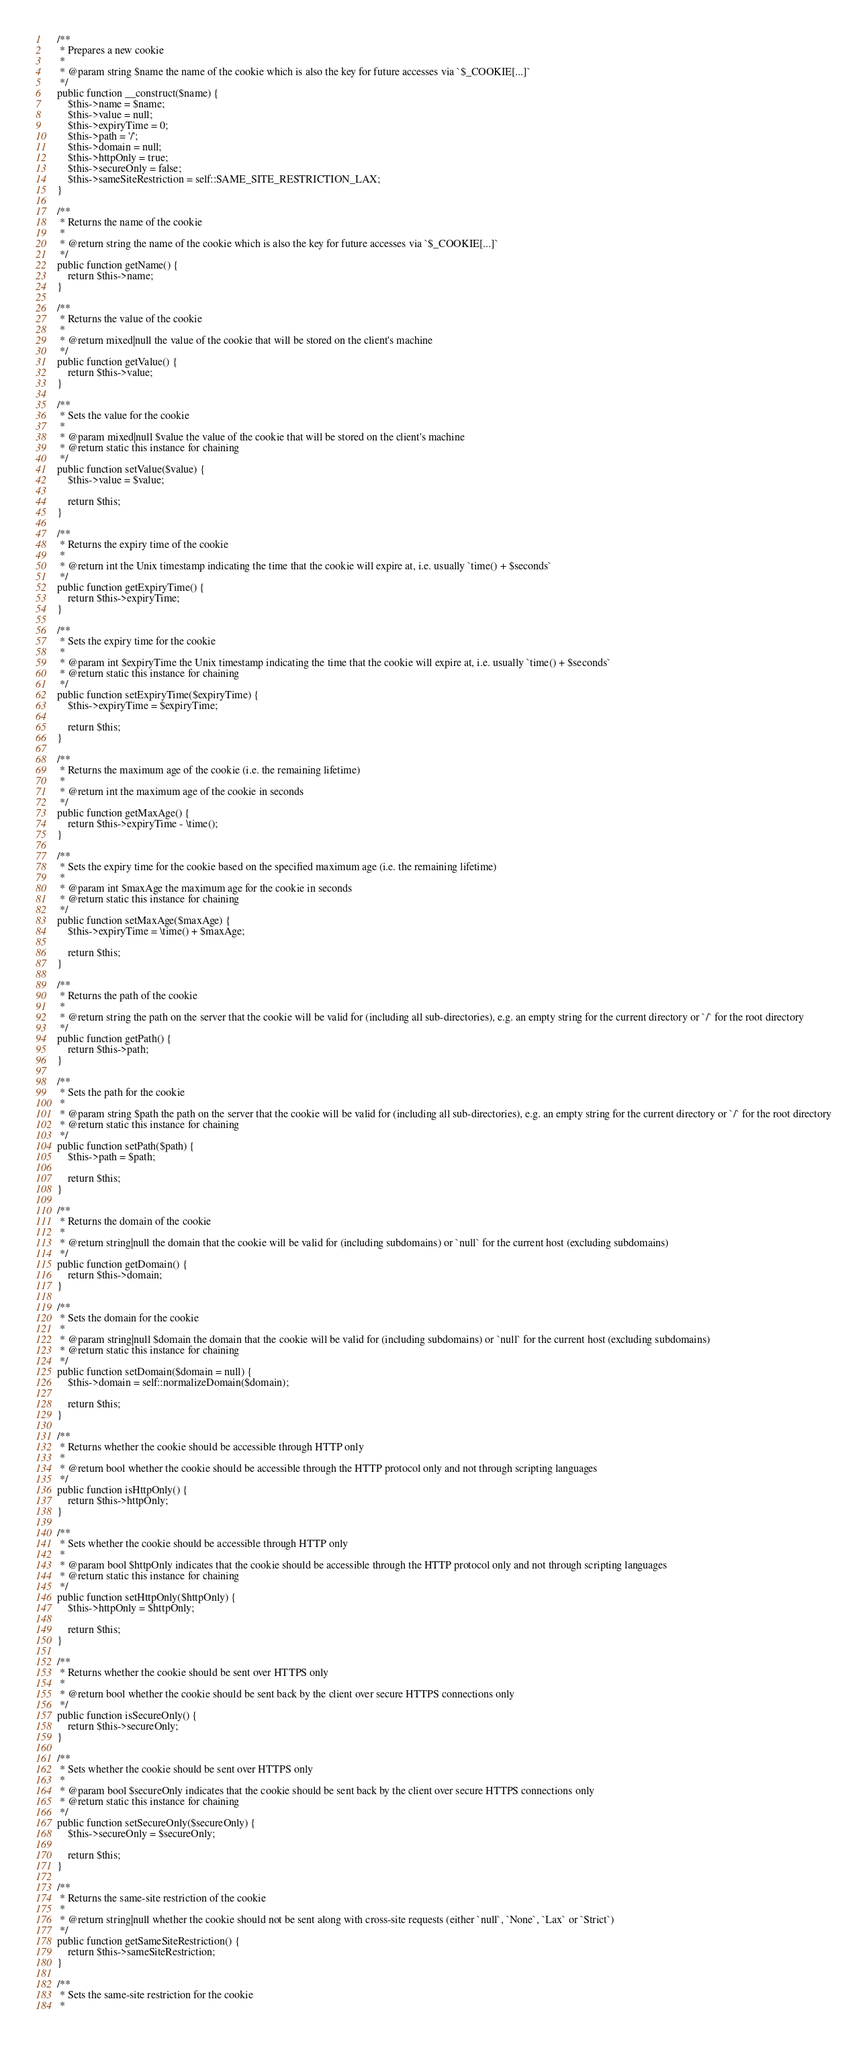Convert code to text. <code><loc_0><loc_0><loc_500><loc_500><_PHP_>
	/**
	 * Prepares a new cookie
	 *
	 * @param string $name the name of the cookie which is also the key for future accesses via `$_COOKIE[...]`
	 */
	public function __construct($name) {
		$this->name = $name;
		$this->value = null;
		$this->expiryTime = 0;
		$this->path = '/';
		$this->domain = null;
		$this->httpOnly = true;
		$this->secureOnly = false;
		$this->sameSiteRestriction = self::SAME_SITE_RESTRICTION_LAX;
	}

	/**
	 * Returns the name of the cookie
	 *
	 * @return string the name of the cookie which is also the key for future accesses via `$_COOKIE[...]`
	 */
	public function getName() {
		return $this->name;
	}

	/**
	 * Returns the value of the cookie
	 *
	 * @return mixed|null the value of the cookie that will be stored on the client's machine
	 */
	public function getValue() {
		return $this->value;
	}

	/**
	 * Sets the value for the cookie
	 *
	 * @param mixed|null $value the value of the cookie that will be stored on the client's machine
	 * @return static this instance for chaining
	 */
	public function setValue($value) {
		$this->value = $value;

		return $this;
	}

	/**
	 * Returns the expiry time of the cookie
	 *
	 * @return int the Unix timestamp indicating the time that the cookie will expire at, i.e. usually `time() + $seconds`
	 */
	public function getExpiryTime() {
		return $this->expiryTime;
	}

	/**
	 * Sets the expiry time for the cookie
	 *
	 * @param int $expiryTime the Unix timestamp indicating the time that the cookie will expire at, i.e. usually `time() + $seconds`
	 * @return static this instance for chaining
	 */
	public function setExpiryTime($expiryTime) {
		$this->expiryTime = $expiryTime;

		return $this;
	}

	/**
	 * Returns the maximum age of the cookie (i.e. the remaining lifetime)
	 *
	 * @return int the maximum age of the cookie in seconds
	 */
	public function getMaxAge() {
		return $this->expiryTime - \time();
	}

	/**
	 * Sets the expiry time for the cookie based on the specified maximum age (i.e. the remaining lifetime)
	 *
	 * @param int $maxAge the maximum age for the cookie in seconds
	 * @return static this instance for chaining
	 */
	public function setMaxAge($maxAge) {
		$this->expiryTime = \time() + $maxAge;

		return $this;
	}

	/**
	 * Returns the path of the cookie
	 *
	 * @return string the path on the server that the cookie will be valid for (including all sub-directories), e.g. an empty string for the current directory or `/` for the root directory
	 */
	public function getPath() {
		return $this->path;
	}

	/**
	 * Sets the path for the cookie
	 *
	 * @param string $path the path on the server that the cookie will be valid for (including all sub-directories), e.g. an empty string for the current directory or `/` for the root directory
	 * @return static this instance for chaining
	 */
	public function setPath($path) {
		$this->path = $path;

		return $this;
	}

	/**
	 * Returns the domain of the cookie
	 *
	 * @return string|null the domain that the cookie will be valid for (including subdomains) or `null` for the current host (excluding subdomains)
	 */
	public function getDomain() {
		return $this->domain;
	}

	/**
	 * Sets the domain for the cookie
	 *
	 * @param string|null $domain the domain that the cookie will be valid for (including subdomains) or `null` for the current host (excluding subdomains)
	 * @return static this instance for chaining
	 */
	public function setDomain($domain = null) {
		$this->domain = self::normalizeDomain($domain);

		return $this;
	}

	/**
	 * Returns whether the cookie should be accessible through HTTP only
	 *
	 * @return bool whether the cookie should be accessible through the HTTP protocol only and not through scripting languages
	 */
	public function isHttpOnly() {
		return $this->httpOnly;
	}

	/**
	 * Sets whether the cookie should be accessible through HTTP only
	 *
	 * @param bool $httpOnly indicates that the cookie should be accessible through the HTTP protocol only and not through scripting languages
	 * @return static this instance for chaining
	 */
	public function setHttpOnly($httpOnly) {
		$this->httpOnly = $httpOnly;

		return $this;
	}

	/**
	 * Returns whether the cookie should be sent over HTTPS only
	 *
	 * @return bool whether the cookie should be sent back by the client over secure HTTPS connections only
	 */
	public function isSecureOnly() {
		return $this->secureOnly;
	}

	/**
	 * Sets whether the cookie should be sent over HTTPS only
	 *
	 * @param bool $secureOnly indicates that the cookie should be sent back by the client over secure HTTPS connections only
	 * @return static this instance for chaining
	 */
	public function setSecureOnly($secureOnly) {
		$this->secureOnly = $secureOnly;

		return $this;
	}

	/**
	 * Returns the same-site restriction of the cookie
	 *
	 * @return string|null whether the cookie should not be sent along with cross-site requests (either `null`, `None`, `Lax` or `Strict`)
	 */
	public function getSameSiteRestriction() {
		return $this->sameSiteRestriction;
	}

	/**
	 * Sets the same-site restriction for the cookie
	 *</code> 